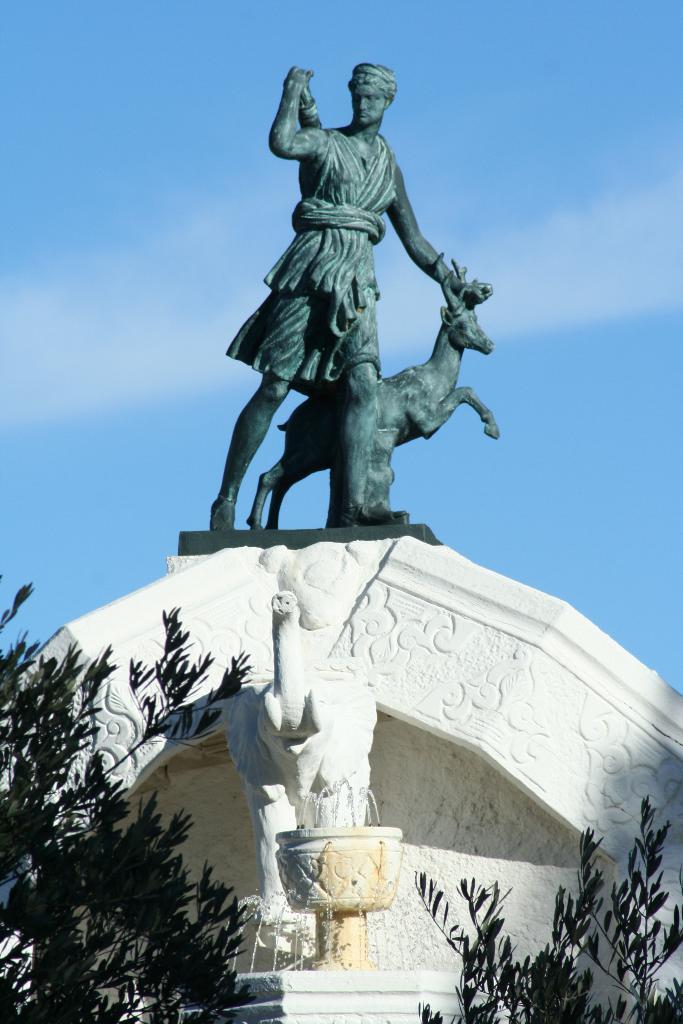Please provide a concise description of this image. In the background we can see the sky. In this picture we can see the statue of a person holding an animal. We can see the plants, water fountain, elephant statue. 